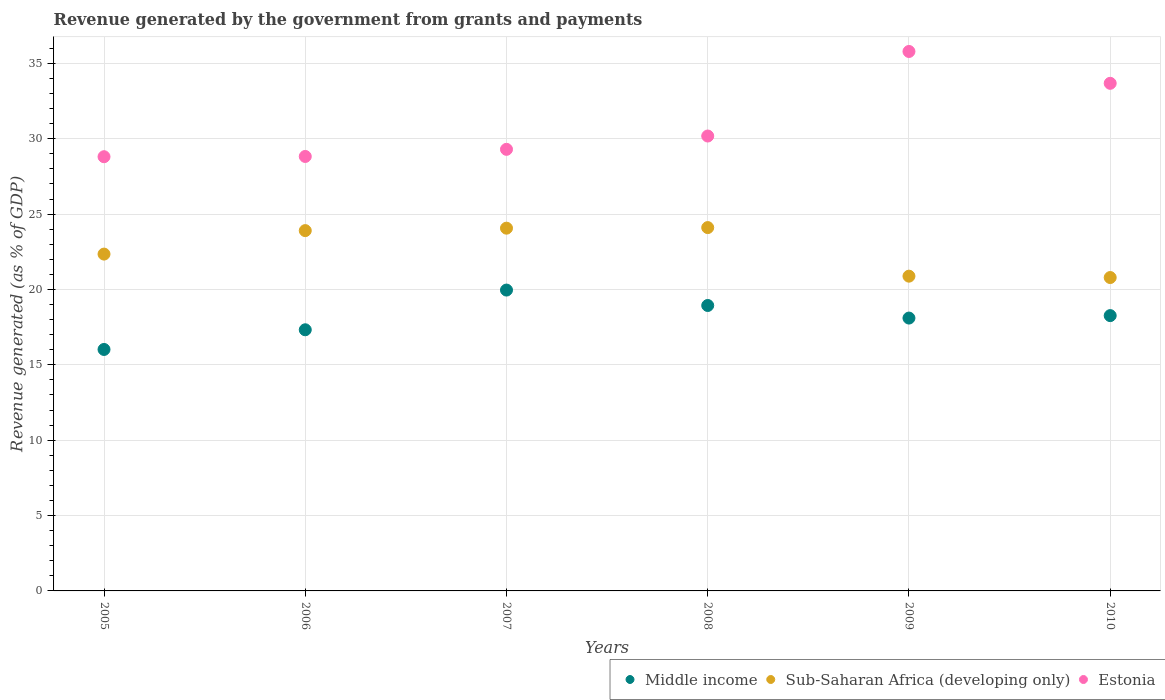How many different coloured dotlines are there?
Your answer should be very brief. 3. What is the revenue generated by the government in Middle income in 2006?
Offer a terse response. 17.33. Across all years, what is the maximum revenue generated by the government in Sub-Saharan Africa (developing only)?
Your answer should be compact. 24.1. Across all years, what is the minimum revenue generated by the government in Estonia?
Give a very brief answer. 28.81. In which year was the revenue generated by the government in Sub-Saharan Africa (developing only) maximum?
Ensure brevity in your answer.  2008. What is the total revenue generated by the government in Middle income in the graph?
Offer a terse response. 108.61. What is the difference between the revenue generated by the government in Middle income in 2006 and that in 2007?
Your answer should be very brief. -2.63. What is the difference between the revenue generated by the government in Sub-Saharan Africa (developing only) in 2006 and the revenue generated by the government in Middle income in 2007?
Ensure brevity in your answer.  3.94. What is the average revenue generated by the government in Middle income per year?
Ensure brevity in your answer.  18.1. In the year 2005, what is the difference between the revenue generated by the government in Sub-Saharan Africa (developing only) and revenue generated by the government in Estonia?
Your answer should be very brief. -6.46. What is the ratio of the revenue generated by the government in Estonia in 2008 to that in 2009?
Make the answer very short. 0.84. What is the difference between the highest and the second highest revenue generated by the government in Sub-Saharan Africa (developing only)?
Make the answer very short. 0.04. What is the difference between the highest and the lowest revenue generated by the government in Estonia?
Your response must be concise. 6.98. In how many years, is the revenue generated by the government in Sub-Saharan Africa (developing only) greater than the average revenue generated by the government in Sub-Saharan Africa (developing only) taken over all years?
Provide a succinct answer. 3. Is the sum of the revenue generated by the government in Estonia in 2005 and 2010 greater than the maximum revenue generated by the government in Middle income across all years?
Offer a terse response. Yes. Is the revenue generated by the government in Middle income strictly less than the revenue generated by the government in Estonia over the years?
Keep it short and to the point. Yes. How many years are there in the graph?
Provide a short and direct response. 6. Does the graph contain any zero values?
Make the answer very short. No. Where does the legend appear in the graph?
Offer a terse response. Bottom right. How are the legend labels stacked?
Keep it short and to the point. Horizontal. What is the title of the graph?
Provide a short and direct response. Revenue generated by the government from grants and payments. Does "Least developed countries" appear as one of the legend labels in the graph?
Offer a very short reply. No. What is the label or title of the Y-axis?
Provide a succinct answer. Revenue generated (as % of GDP). What is the Revenue generated (as % of GDP) of Middle income in 2005?
Provide a short and direct response. 16.02. What is the Revenue generated (as % of GDP) in Sub-Saharan Africa (developing only) in 2005?
Offer a very short reply. 22.35. What is the Revenue generated (as % of GDP) in Estonia in 2005?
Your answer should be very brief. 28.81. What is the Revenue generated (as % of GDP) in Middle income in 2006?
Offer a terse response. 17.33. What is the Revenue generated (as % of GDP) of Sub-Saharan Africa (developing only) in 2006?
Your answer should be very brief. 23.9. What is the Revenue generated (as % of GDP) of Estonia in 2006?
Provide a short and direct response. 28.82. What is the Revenue generated (as % of GDP) in Middle income in 2007?
Provide a short and direct response. 19.96. What is the Revenue generated (as % of GDP) of Sub-Saharan Africa (developing only) in 2007?
Your response must be concise. 24.07. What is the Revenue generated (as % of GDP) of Estonia in 2007?
Your answer should be very brief. 29.3. What is the Revenue generated (as % of GDP) of Middle income in 2008?
Offer a terse response. 18.94. What is the Revenue generated (as % of GDP) in Sub-Saharan Africa (developing only) in 2008?
Provide a short and direct response. 24.1. What is the Revenue generated (as % of GDP) in Estonia in 2008?
Your answer should be very brief. 30.18. What is the Revenue generated (as % of GDP) of Middle income in 2009?
Offer a terse response. 18.1. What is the Revenue generated (as % of GDP) in Sub-Saharan Africa (developing only) in 2009?
Provide a succinct answer. 20.88. What is the Revenue generated (as % of GDP) of Estonia in 2009?
Make the answer very short. 35.79. What is the Revenue generated (as % of GDP) in Middle income in 2010?
Offer a very short reply. 18.26. What is the Revenue generated (as % of GDP) in Sub-Saharan Africa (developing only) in 2010?
Your response must be concise. 20.79. What is the Revenue generated (as % of GDP) in Estonia in 2010?
Keep it short and to the point. 33.68. Across all years, what is the maximum Revenue generated (as % of GDP) in Middle income?
Your answer should be compact. 19.96. Across all years, what is the maximum Revenue generated (as % of GDP) of Sub-Saharan Africa (developing only)?
Give a very brief answer. 24.1. Across all years, what is the maximum Revenue generated (as % of GDP) in Estonia?
Offer a very short reply. 35.79. Across all years, what is the minimum Revenue generated (as % of GDP) of Middle income?
Offer a very short reply. 16.02. Across all years, what is the minimum Revenue generated (as % of GDP) of Sub-Saharan Africa (developing only)?
Make the answer very short. 20.79. Across all years, what is the minimum Revenue generated (as % of GDP) in Estonia?
Make the answer very short. 28.81. What is the total Revenue generated (as % of GDP) in Middle income in the graph?
Keep it short and to the point. 108.61. What is the total Revenue generated (as % of GDP) in Sub-Saharan Africa (developing only) in the graph?
Provide a short and direct response. 136.09. What is the total Revenue generated (as % of GDP) of Estonia in the graph?
Make the answer very short. 186.57. What is the difference between the Revenue generated (as % of GDP) in Middle income in 2005 and that in 2006?
Make the answer very short. -1.31. What is the difference between the Revenue generated (as % of GDP) in Sub-Saharan Africa (developing only) in 2005 and that in 2006?
Provide a succinct answer. -1.56. What is the difference between the Revenue generated (as % of GDP) in Estonia in 2005 and that in 2006?
Ensure brevity in your answer.  -0.02. What is the difference between the Revenue generated (as % of GDP) of Middle income in 2005 and that in 2007?
Your answer should be very brief. -3.94. What is the difference between the Revenue generated (as % of GDP) in Sub-Saharan Africa (developing only) in 2005 and that in 2007?
Your answer should be very brief. -1.72. What is the difference between the Revenue generated (as % of GDP) of Estonia in 2005 and that in 2007?
Ensure brevity in your answer.  -0.49. What is the difference between the Revenue generated (as % of GDP) in Middle income in 2005 and that in 2008?
Ensure brevity in your answer.  -2.92. What is the difference between the Revenue generated (as % of GDP) in Sub-Saharan Africa (developing only) in 2005 and that in 2008?
Offer a very short reply. -1.76. What is the difference between the Revenue generated (as % of GDP) of Estonia in 2005 and that in 2008?
Give a very brief answer. -1.37. What is the difference between the Revenue generated (as % of GDP) of Middle income in 2005 and that in 2009?
Ensure brevity in your answer.  -2.08. What is the difference between the Revenue generated (as % of GDP) in Sub-Saharan Africa (developing only) in 2005 and that in 2009?
Your response must be concise. 1.46. What is the difference between the Revenue generated (as % of GDP) of Estonia in 2005 and that in 2009?
Ensure brevity in your answer.  -6.98. What is the difference between the Revenue generated (as % of GDP) in Middle income in 2005 and that in 2010?
Offer a very short reply. -2.25. What is the difference between the Revenue generated (as % of GDP) in Sub-Saharan Africa (developing only) in 2005 and that in 2010?
Offer a terse response. 1.56. What is the difference between the Revenue generated (as % of GDP) in Estonia in 2005 and that in 2010?
Offer a very short reply. -4.87. What is the difference between the Revenue generated (as % of GDP) in Middle income in 2006 and that in 2007?
Make the answer very short. -2.63. What is the difference between the Revenue generated (as % of GDP) in Sub-Saharan Africa (developing only) in 2006 and that in 2007?
Offer a very short reply. -0.16. What is the difference between the Revenue generated (as % of GDP) in Estonia in 2006 and that in 2007?
Your answer should be very brief. -0.47. What is the difference between the Revenue generated (as % of GDP) of Middle income in 2006 and that in 2008?
Your response must be concise. -1.61. What is the difference between the Revenue generated (as % of GDP) in Sub-Saharan Africa (developing only) in 2006 and that in 2008?
Offer a very short reply. -0.2. What is the difference between the Revenue generated (as % of GDP) of Estonia in 2006 and that in 2008?
Your answer should be very brief. -1.36. What is the difference between the Revenue generated (as % of GDP) in Middle income in 2006 and that in 2009?
Make the answer very short. -0.78. What is the difference between the Revenue generated (as % of GDP) of Sub-Saharan Africa (developing only) in 2006 and that in 2009?
Your answer should be compact. 3.02. What is the difference between the Revenue generated (as % of GDP) in Estonia in 2006 and that in 2009?
Provide a succinct answer. -6.97. What is the difference between the Revenue generated (as % of GDP) of Middle income in 2006 and that in 2010?
Give a very brief answer. -0.94. What is the difference between the Revenue generated (as % of GDP) of Sub-Saharan Africa (developing only) in 2006 and that in 2010?
Provide a succinct answer. 3.11. What is the difference between the Revenue generated (as % of GDP) of Estonia in 2006 and that in 2010?
Offer a terse response. -4.85. What is the difference between the Revenue generated (as % of GDP) in Middle income in 2007 and that in 2008?
Your answer should be compact. 1.02. What is the difference between the Revenue generated (as % of GDP) of Sub-Saharan Africa (developing only) in 2007 and that in 2008?
Your answer should be very brief. -0.04. What is the difference between the Revenue generated (as % of GDP) of Estonia in 2007 and that in 2008?
Keep it short and to the point. -0.88. What is the difference between the Revenue generated (as % of GDP) in Middle income in 2007 and that in 2009?
Your answer should be compact. 1.86. What is the difference between the Revenue generated (as % of GDP) in Sub-Saharan Africa (developing only) in 2007 and that in 2009?
Keep it short and to the point. 3.18. What is the difference between the Revenue generated (as % of GDP) in Estonia in 2007 and that in 2009?
Provide a short and direct response. -6.49. What is the difference between the Revenue generated (as % of GDP) in Middle income in 2007 and that in 2010?
Your answer should be very brief. 1.69. What is the difference between the Revenue generated (as % of GDP) in Sub-Saharan Africa (developing only) in 2007 and that in 2010?
Provide a short and direct response. 3.28. What is the difference between the Revenue generated (as % of GDP) in Estonia in 2007 and that in 2010?
Give a very brief answer. -4.38. What is the difference between the Revenue generated (as % of GDP) of Middle income in 2008 and that in 2009?
Give a very brief answer. 0.83. What is the difference between the Revenue generated (as % of GDP) of Sub-Saharan Africa (developing only) in 2008 and that in 2009?
Ensure brevity in your answer.  3.22. What is the difference between the Revenue generated (as % of GDP) in Estonia in 2008 and that in 2009?
Your answer should be compact. -5.61. What is the difference between the Revenue generated (as % of GDP) in Middle income in 2008 and that in 2010?
Offer a very short reply. 0.67. What is the difference between the Revenue generated (as % of GDP) of Sub-Saharan Africa (developing only) in 2008 and that in 2010?
Ensure brevity in your answer.  3.31. What is the difference between the Revenue generated (as % of GDP) in Estonia in 2008 and that in 2010?
Keep it short and to the point. -3.5. What is the difference between the Revenue generated (as % of GDP) of Middle income in 2009 and that in 2010?
Provide a short and direct response. -0.16. What is the difference between the Revenue generated (as % of GDP) of Sub-Saharan Africa (developing only) in 2009 and that in 2010?
Keep it short and to the point. 0.09. What is the difference between the Revenue generated (as % of GDP) in Estonia in 2009 and that in 2010?
Provide a short and direct response. 2.11. What is the difference between the Revenue generated (as % of GDP) in Middle income in 2005 and the Revenue generated (as % of GDP) in Sub-Saharan Africa (developing only) in 2006?
Offer a terse response. -7.88. What is the difference between the Revenue generated (as % of GDP) of Middle income in 2005 and the Revenue generated (as % of GDP) of Estonia in 2006?
Your answer should be compact. -12.8. What is the difference between the Revenue generated (as % of GDP) of Sub-Saharan Africa (developing only) in 2005 and the Revenue generated (as % of GDP) of Estonia in 2006?
Ensure brevity in your answer.  -6.48. What is the difference between the Revenue generated (as % of GDP) in Middle income in 2005 and the Revenue generated (as % of GDP) in Sub-Saharan Africa (developing only) in 2007?
Offer a very short reply. -8.05. What is the difference between the Revenue generated (as % of GDP) of Middle income in 2005 and the Revenue generated (as % of GDP) of Estonia in 2007?
Ensure brevity in your answer.  -13.28. What is the difference between the Revenue generated (as % of GDP) of Sub-Saharan Africa (developing only) in 2005 and the Revenue generated (as % of GDP) of Estonia in 2007?
Give a very brief answer. -6.95. What is the difference between the Revenue generated (as % of GDP) of Middle income in 2005 and the Revenue generated (as % of GDP) of Sub-Saharan Africa (developing only) in 2008?
Give a very brief answer. -8.09. What is the difference between the Revenue generated (as % of GDP) in Middle income in 2005 and the Revenue generated (as % of GDP) in Estonia in 2008?
Your answer should be very brief. -14.16. What is the difference between the Revenue generated (as % of GDP) in Sub-Saharan Africa (developing only) in 2005 and the Revenue generated (as % of GDP) in Estonia in 2008?
Offer a very short reply. -7.83. What is the difference between the Revenue generated (as % of GDP) of Middle income in 2005 and the Revenue generated (as % of GDP) of Sub-Saharan Africa (developing only) in 2009?
Provide a succinct answer. -4.86. What is the difference between the Revenue generated (as % of GDP) in Middle income in 2005 and the Revenue generated (as % of GDP) in Estonia in 2009?
Provide a succinct answer. -19.77. What is the difference between the Revenue generated (as % of GDP) in Sub-Saharan Africa (developing only) in 2005 and the Revenue generated (as % of GDP) in Estonia in 2009?
Offer a very short reply. -13.44. What is the difference between the Revenue generated (as % of GDP) of Middle income in 2005 and the Revenue generated (as % of GDP) of Sub-Saharan Africa (developing only) in 2010?
Your response must be concise. -4.77. What is the difference between the Revenue generated (as % of GDP) of Middle income in 2005 and the Revenue generated (as % of GDP) of Estonia in 2010?
Offer a very short reply. -17.66. What is the difference between the Revenue generated (as % of GDP) of Sub-Saharan Africa (developing only) in 2005 and the Revenue generated (as % of GDP) of Estonia in 2010?
Make the answer very short. -11.33. What is the difference between the Revenue generated (as % of GDP) in Middle income in 2006 and the Revenue generated (as % of GDP) in Sub-Saharan Africa (developing only) in 2007?
Make the answer very short. -6.74. What is the difference between the Revenue generated (as % of GDP) in Middle income in 2006 and the Revenue generated (as % of GDP) in Estonia in 2007?
Your answer should be very brief. -11.97. What is the difference between the Revenue generated (as % of GDP) of Sub-Saharan Africa (developing only) in 2006 and the Revenue generated (as % of GDP) of Estonia in 2007?
Offer a terse response. -5.39. What is the difference between the Revenue generated (as % of GDP) of Middle income in 2006 and the Revenue generated (as % of GDP) of Sub-Saharan Africa (developing only) in 2008?
Provide a succinct answer. -6.78. What is the difference between the Revenue generated (as % of GDP) in Middle income in 2006 and the Revenue generated (as % of GDP) in Estonia in 2008?
Your answer should be compact. -12.85. What is the difference between the Revenue generated (as % of GDP) of Sub-Saharan Africa (developing only) in 2006 and the Revenue generated (as % of GDP) of Estonia in 2008?
Offer a very short reply. -6.28. What is the difference between the Revenue generated (as % of GDP) in Middle income in 2006 and the Revenue generated (as % of GDP) in Sub-Saharan Africa (developing only) in 2009?
Give a very brief answer. -3.56. What is the difference between the Revenue generated (as % of GDP) of Middle income in 2006 and the Revenue generated (as % of GDP) of Estonia in 2009?
Ensure brevity in your answer.  -18.46. What is the difference between the Revenue generated (as % of GDP) of Sub-Saharan Africa (developing only) in 2006 and the Revenue generated (as % of GDP) of Estonia in 2009?
Keep it short and to the point. -11.88. What is the difference between the Revenue generated (as % of GDP) of Middle income in 2006 and the Revenue generated (as % of GDP) of Sub-Saharan Africa (developing only) in 2010?
Make the answer very short. -3.47. What is the difference between the Revenue generated (as % of GDP) of Middle income in 2006 and the Revenue generated (as % of GDP) of Estonia in 2010?
Your answer should be very brief. -16.35. What is the difference between the Revenue generated (as % of GDP) in Sub-Saharan Africa (developing only) in 2006 and the Revenue generated (as % of GDP) in Estonia in 2010?
Ensure brevity in your answer.  -9.77. What is the difference between the Revenue generated (as % of GDP) in Middle income in 2007 and the Revenue generated (as % of GDP) in Sub-Saharan Africa (developing only) in 2008?
Ensure brevity in your answer.  -4.15. What is the difference between the Revenue generated (as % of GDP) in Middle income in 2007 and the Revenue generated (as % of GDP) in Estonia in 2008?
Your response must be concise. -10.22. What is the difference between the Revenue generated (as % of GDP) in Sub-Saharan Africa (developing only) in 2007 and the Revenue generated (as % of GDP) in Estonia in 2008?
Keep it short and to the point. -6.11. What is the difference between the Revenue generated (as % of GDP) of Middle income in 2007 and the Revenue generated (as % of GDP) of Sub-Saharan Africa (developing only) in 2009?
Offer a terse response. -0.92. What is the difference between the Revenue generated (as % of GDP) of Middle income in 2007 and the Revenue generated (as % of GDP) of Estonia in 2009?
Ensure brevity in your answer.  -15.83. What is the difference between the Revenue generated (as % of GDP) of Sub-Saharan Africa (developing only) in 2007 and the Revenue generated (as % of GDP) of Estonia in 2009?
Offer a very short reply. -11.72. What is the difference between the Revenue generated (as % of GDP) in Middle income in 2007 and the Revenue generated (as % of GDP) in Sub-Saharan Africa (developing only) in 2010?
Give a very brief answer. -0.83. What is the difference between the Revenue generated (as % of GDP) of Middle income in 2007 and the Revenue generated (as % of GDP) of Estonia in 2010?
Your response must be concise. -13.72. What is the difference between the Revenue generated (as % of GDP) in Sub-Saharan Africa (developing only) in 2007 and the Revenue generated (as % of GDP) in Estonia in 2010?
Offer a terse response. -9.61. What is the difference between the Revenue generated (as % of GDP) of Middle income in 2008 and the Revenue generated (as % of GDP) of Sub-Saharan Africa (developing only) in 2009?
Ensure brevity in your answer.  -1.95. What is the difference between the Revenue generated (as % of GDP) in Middle income in 2008 and the Revenue generated (as % of GDP) in Estonia in 2009?
Provide a short and direct response. -16.85. What is the difference between the Revenue generated (as % of GDP) in Sub-Saharan Africa (developing only) in 2008 and the Revenue generated (as % of GDP) in Estonia in 2009?
Make the answer very short. -11.68. What is the difference between the Revenue generated (as % of GDP) in Middle income in 2008 and the Revenue generated (as % of GDP) in Sub-Saharan Africa (developing only) in 2010?
Make the answer very short. -1.85. What is the difference between the Revenue generated (as % of GDP) in Middle income in 2008 and the Revenue generated (as % of GDP) in Estonia in 2010?
Make the answer very short. -14.74. What is the difference between the Revenue generated (as % of GDP) of Sub-Saharan Africa (developing only) in 2008 and the Revenue generated (as % of GDP) of Estonia in 2010?
Offer a terse response. -9.57. What is the difference between the Revenue generated (as % of GDP) of Middle income in 2009 and the Revenue generated (as % of GDP) of Sub-Saharan Africa (developing only) in 2010?
Provide a succinct answer. -2.69. What is the difference between the Revenue generated (as % of GDP) in Middle income in 2009 and the Revenue generated (as % of GDP) in Estonia in 2010?
Ensure brevity in your answer.  -15.57. What is the difference between the Revenue generated (as % of GDP) in Sub-Saharan Africa (developing only) in 2009 and the Revenue generated (as % of GDP) in Estonia in 2010?
Keep it short and to the point. -12.79. What is the average Revenue generated (as % of GDP) of Middle income per year?
Offer a very short reply. 18.1. What is the average Revenue generated (as % of GDP) in Sub-Saharan Africa (developing only) per year?
Offer a terse response. 22.68. What is the average Revenue generated (as % of GDP) of Estonia per year?
Offer a very short reply. 31.09. In the year 2005, what is the difference between the Revenue generated (as % of GDP) in Middle income and Revenue generated (as % of GDP) in Sub-Saharan Africa (developing only)?
Provide a short and direct response. -6.33. In the year 2005, what is the difference between the Revenue generated (as % of GDP) in Middle income and Revenue generated (as % of GDP) in Estonia?
Your response must be concise. -12.79. In the year 2005, what is the difference between the Revenue generated (as % of GDP) of Sub-Saharan Africa (developing only) and Revenue generated (as % of GDP) of Estonia?
Your answer should be very brief. -6.46. In the year 2006, what is the difference between the Revenue generated (as % of GDP) of Middle income and Revenue generated (as % of GDP) of Sub-Saharan Africa (developing only)?
Offer a very short reply. -6.58. In the year 2006, what is the difference between the Revenue generated (as % of GDP) of Middle income and Revenue generated (as % of GDP) of Estonia?
Provide a succinct answer. -11.5. In the year 2006, what is the difference between the Revenue generated (as % of GDP) of Sub-Saharan Africa (developing only) and Revenue generated (as % of GDP) of Estonia?
Your answer should be compact. -4.92. In the year 2007, what is the difference between the Revenue generated (as % of GDP) of Middle income and Revenue generated (as % of GDP) of Sub-Saharan Africa (developing only)?
Make the answer very short. -4.11. In the year 2007, what is the difference between the Revenue generated (as % of GDP) of Middle income and Revenue generated (as % of GDP) of Estonia?
Your answer should be compact. -9.34. In the year 2007, what is the difference between the Revenue generated (as % of GDP) of Sub-Saharan Africa (developing only) and Revenue generated (as % of GDP) of Estonia?
Ensure brevity in your answer.  -5.23. In the year 2008, what is the difference between the Revenue generated (as % of GDP) of Middle income and Revenue generated (as % of GDP) of Sub-Saharan Africa (developing only)?
Offer a terse response. -5.17. In the year 2008, what is the difference between the Revenue generated (as % of GDP) of Middle income and Revenue generated (as % of GDP) of Estonia?
Keep it short and to the point. -11.24. In the year 2008, what is the difference between the Revenue generated (as % of GDP) of Sub-Saharan Africa (developing only) and Revenue generated (as % of GDP) of Estonia?
Offer a terse response. -6.07. In the year 2009, what is the difference between the Revenue generated (as % of GDP) in Middle income and Revenue generated (as % of GDP) in Sub-Saharan Africa (developing only)?
Provide a short and direct response. -2.78. In the year 2009, what is the difference between the Revenue generated (as % of GDP) in Middle income and Revenue generated (as % of GDP) in Estonia?
Your answer should be compact. -17.69. In the year 2009, what is the difference between the Revenue generated (as % of GDP) in Sub-Saharan Africa (developing only) and Revenue generated (as % of GDP) in Estonia?
Keep it short and to the point. -14.91. In the year 2010, what is the difference between the Revenue generated (as % of GDP) in Middle income and Revenue generated (as % of GDP) in Sub-Saharan Africa (developing only)?
Your answer should be very brief. -2.53. In the year 2010, what is the difference between the Revenue generated (as % of GDP) of Middle income and Revenue generated (as % of GDP) of Estonia?
Ensure brevity in your answer.  -15.41. In the year 2010, what is the difference between the Revenue generated (as % of GDP) in Sub-Saharan Africa (developing only) and Revenue generated (as % of GDP) in Estonia?
Your answer should be very brief. -12.89. What is the ratio of the Revenue generated (as % of GDP) of Middle income in 2005 to that in 2006?
Offer a terse response. 0.92. What is the ratio of the Revenue generated (as % of GDP) in Sub-Saharan Africa (developing only) in 2005 to that in 2006?
Offer a terse response. 0.93. What is the ratio of the Revenue generated (as % of GDP) in Middle income in 2005 to that in 2007?
Offer a terse response. 0.8. What is the ratio of the Revenue generated (as % of GDP) of Sub-Saharan Africa (developing only) in 2005 to that in 2007?
Offer a very short reply. 0.93. What is the ratio of the Revenue generated (as % of GDP) in Estonia in 2005 to that in 2007?
Give a very brief answer. 0.98. What is the ratio of the Revenue generated (as % of GDP) of Middle income in 2005 to that in 2008?
Offer a very short reply. 0.85. What is the ratio of the Revenue generated (as % of GDP) of Sub-Saharan Africa (developing only) in 2005 to that in 2008?
Offer a terse response. 0.93. What is the ratio of the Revenue generated (as % of GDP) in Estonia in 2005 to that in 2008?
Your answer should be compact. 0.95. What is the ratio of the Revenue generated (as % of GDP) in Middle income in 2005 to that in 2009?
Provide a succinct answer. 0.89. What is the ratio of the Revenue generated (as % of GDP) in Sub-Saharan Africa (developing only) in 2005 to that in 2009?
Provide a succinct answer. 1.07. What is the ratio of the Revenue generated (as % of GDP) of Estonia in 2005 to that in 2009?
Your response must be concise. 0.8. What is the ratio of the Revenue generated (as % of GDP) of Middle income in 2005 to that in 2010?
Keep it short and to the point. 0.88. What is the ratio of the Revenue generated (as % of GDP) of Sub-Saharan Africa (developing only) in 2005 to that in 2010?
Offer a very short reply. 1.07. What is the ratio of the Revenue generated (as % of GDP) in Estonia in 2005 to that in 2010?
Ensure brevity in your answer.  0.86. What is the ratio of the Revenue generated (as % of GDP) in Middle income in 2006 to that in 2007?
Your response must be concise. 0.87. What is the ratio of the Revenue generated (as % of GDP) of Sub-Saharan Africa (developing only) in 2006 to that in 2007?
Provide a short and direct response. 0.99. What is the ratio of the Revenue generated (as % of GDP) in Estonia in 2006 to that in 2007?
Keep it short and to the point. 0.98. What is the ratio of the Revenue generated (as % of GDP) in Middle income in 2006 to that in 2008?
Your response must be concise. 0.91. What is the ratio of the Revenue generated (as % of GDP) of Sub-Saharan Africa (developing only) in 2006 to that in 2008?
Your answer should be compact. 0.99. What is the ratio of the Revenue generated (as % of GDP) of Estonia in 2006 to that in 2008?
Ensure brevity in your answer.  0.96. What is the ratio of the Revenue generated (as % of GDP) in Middle income in 2006 to that in 2009?
Make the answer very short. 0.96. What is the ratio of the Revenue generated (as % of GDP) of Sub-Saharan Africa (developing only) in 2006 to that in 2009?
Keep it short and to the point. 1.14. What is the ratio of the Revenue generated (as % of GDP) in Estonia in 2006 to that in 2009?
Your response must be concise. 0.81. What is the ratio of the Revenue generated (as % of GDP) in Middle income in 2006 to that in 2010?
Offer a very short reply. 0.95. What is the ratio of the Revenue generated (as % of GDP) in Sub-Saharan Africa (developing only) in 2006 to that in 2010?
Make the answer very short. 1.15. What is the ratio of the Revenue generated (as % of GDP) of Estonia in 2006 to that in 2010?
Your answer should be compact. 0.86. What is the ratio of the Revenue generated (as % of GDP) of Middle income in 2007 to that in 2008?
Your answer should be compact. 1.05. What is the ratio of the Revenue generated (as % of GDP) of Estonia in 2007 to that in 2008?
Provide a succinct answer. 0.97. What is the ratio of the Revenue generated (as % of GDP) of Middle income in 2007 to that in 2009?
Offer a terse response. 1.1. What is the ratio of the Revenue generated (as % of GDP) in Sub-Saharan Africa (developing only) in 2007 to that in 2009?
Offer a terse response. 1.15. What is the ratio of the Revenue generated (as % of GDP) of Estonia in 2007 to that in 2009?
Keep it short and to the point. 0.82. What is the ratio of the Revenue generated (as % of GDP) of Middle income in 2007 to that in 2010?
Give a very brief answer. 1.09. What is the ratio of the Revenue generated (as % of GDP) of Sub-Saharan Africa (developing only) in 2007 to that in 2010?
Your answer should be compact. 1.16. What is the ratio of the Revenue generated (as % of GDP) in Estonia in 2007 to that in 2010?
Your response must be concise. 0.87. What is the ratio of the Revenue generated (as % of GDP) in Middle income in 2008 to that in 2009?
Offer a terse response. 1.05. What is the ratio of the Revenue generated (as % of GDP) of Sub-Saharan Africa (developing only) in 2008 to that in 2009?
Offer a very short reply. 1.15. What is the ratio of the Revenue generated (as % of GDP) of Estonia in 2008 to that in 2009?
Your answer should be compact. 0.84. What is the ratio of the Revenue generated (as % of GDP) in Middle income in 2008 to that in 2010?
Your response must be concise. 1.04. What is the ratio of the Revenue generated (as % of GDP) of Sub-Saharan Africa (developing only) in 2008 to that in 2010?
Provide a short and direct response. 1.16. What is the ratio of the Revenue generated (as % of GDP) in Estonia in 2008 to that in 2010?
Make the answer very short. 0.9. What is the ratio of the Revenue generated (as % of GDP) in Sub-Saharan Africa (developing only) in 2009 to that in 2010?
Offer a terse response. 1. What is the ratio of the Revenue generated (as % of GDP) of Estonia in 2009 to that in 2010?
Provide a succinct answer. 1.06. What is the difference between the highest and the second highest Revenue generated (as % of GDP) of Middle income?
Ensure brevity in your answer.  1.02. What is the difference between the highest and the second highest Revenue generated (as % of GDP) of Sub-Saharan Africa (developing only)?
Make the answer very short. 0.04. What is the difference between the highest and the second highest Revenue generated (as % of GDP) in Estonia?
Your response must be concise. 2.11. What is the difference between the highest and the lowest Revenue generated (as % of GDP) of Middle income?
Your answer should be compact. 3.94. What is the difference between the highest and the lowest Revenue generated (as % of GDP) of Sub-Saharan Africa (developing only)?
Ensure brevity in your answer.  3.31. What is the difference between the highest and the lowest Revenue generated (as % of GDP) in Estonia?
Ensure brevity in your answer.  6.98. 